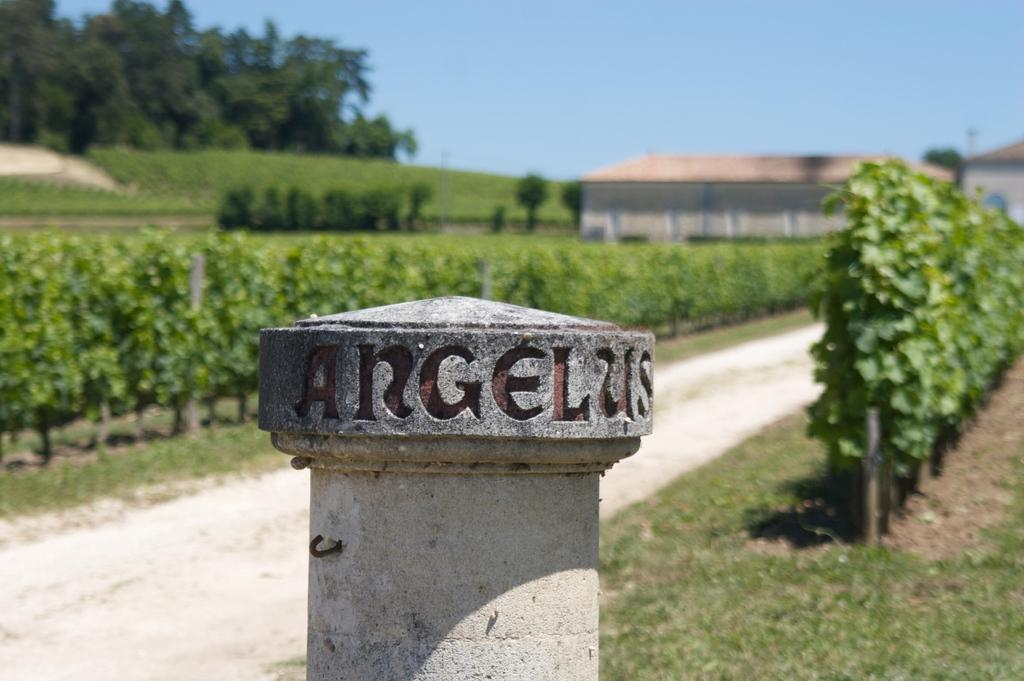What is on the pole that is visible in the image? There is text on the pole in the image. What type of vegetation can be seen in the image? There are plants, grass, and trees in the image. What is visible on the ground in the image? The ground is visible in the image, and there is grass on it. What type of structures are visible in the image? There are houses in the image. What is visible at the top of the image? The sky is visible in the image. Can you see a lipstick-wearing bridge in the image? There is no lipstick-wearing bridge present in the image. What type of creature is looking at the houses in the image? There is no creature looking at the houses in the image. 